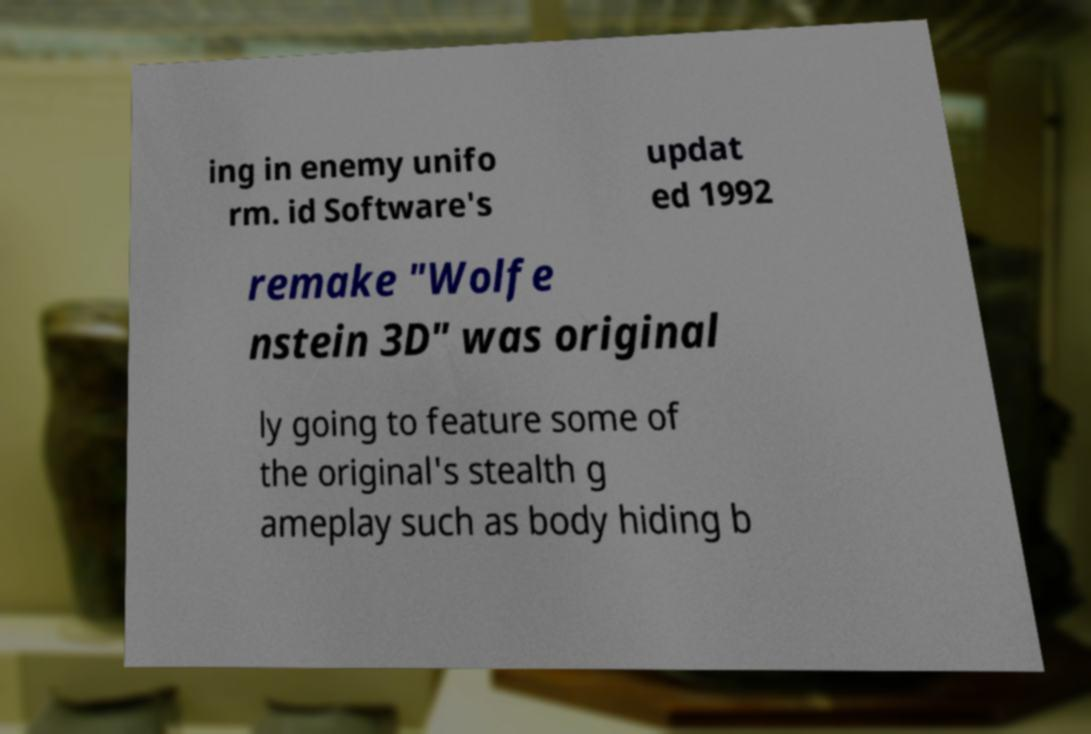Could you extract and type out the text from this image? ing in enemy unifo rm. id Software's updat ed 1992 remake "Wolfe nstein 3D" was original ly going to feature some of the original's stealth g ameplay such as body hiding b 